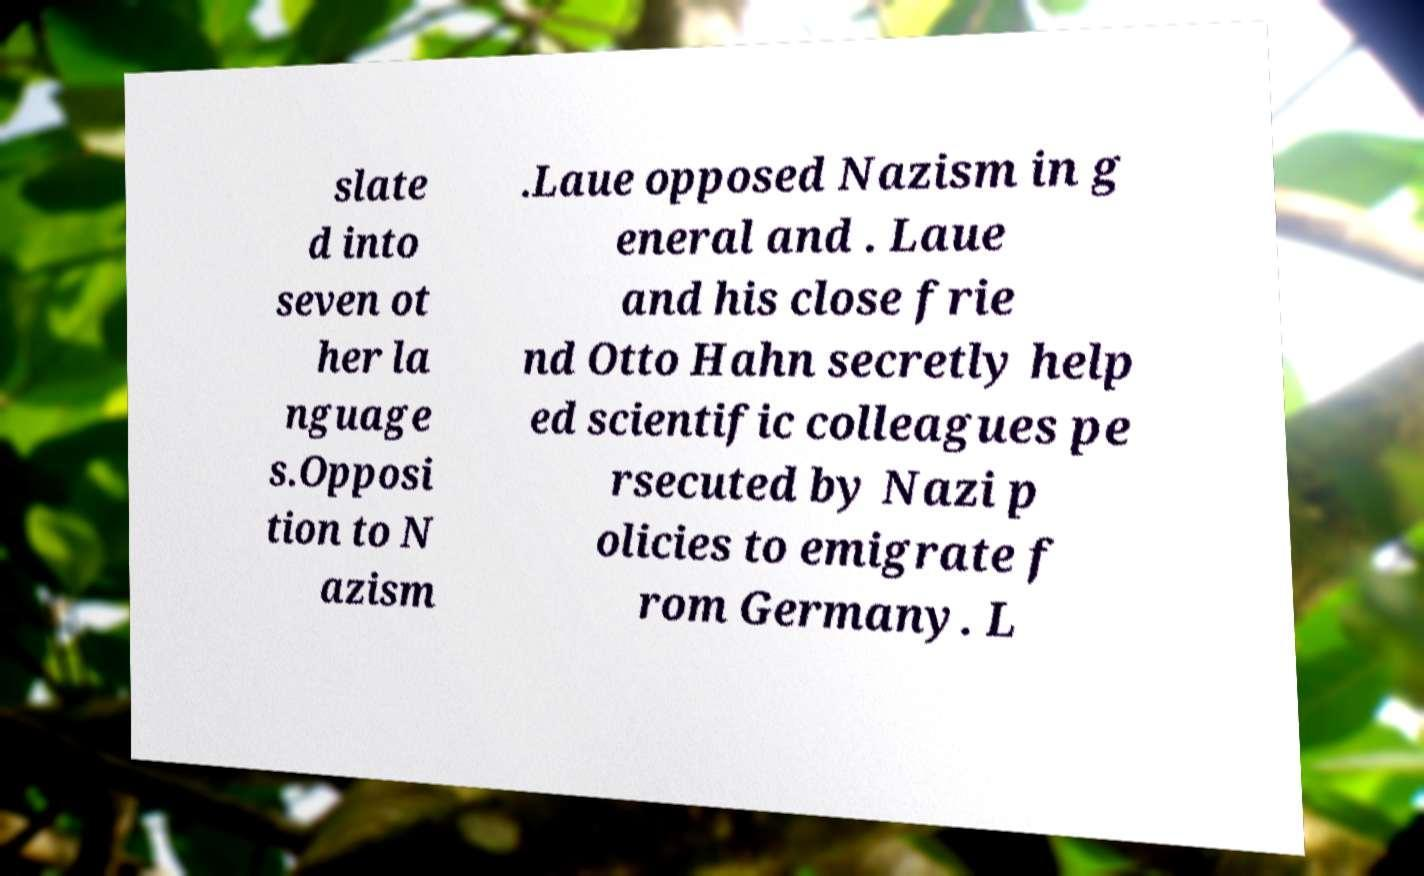For documentation purposes, I need the text within this image transcribed. Could you provide that? slate d into seven ot her la nguage s.Opposi tion to N azism .Laue opposed Nazism in g eneral and . Laue and his close frie nd Otto Hahn secretly help ed scientific colleagues pe rsecuted by Nazi p olicies to emigrate f rom Germany. L 